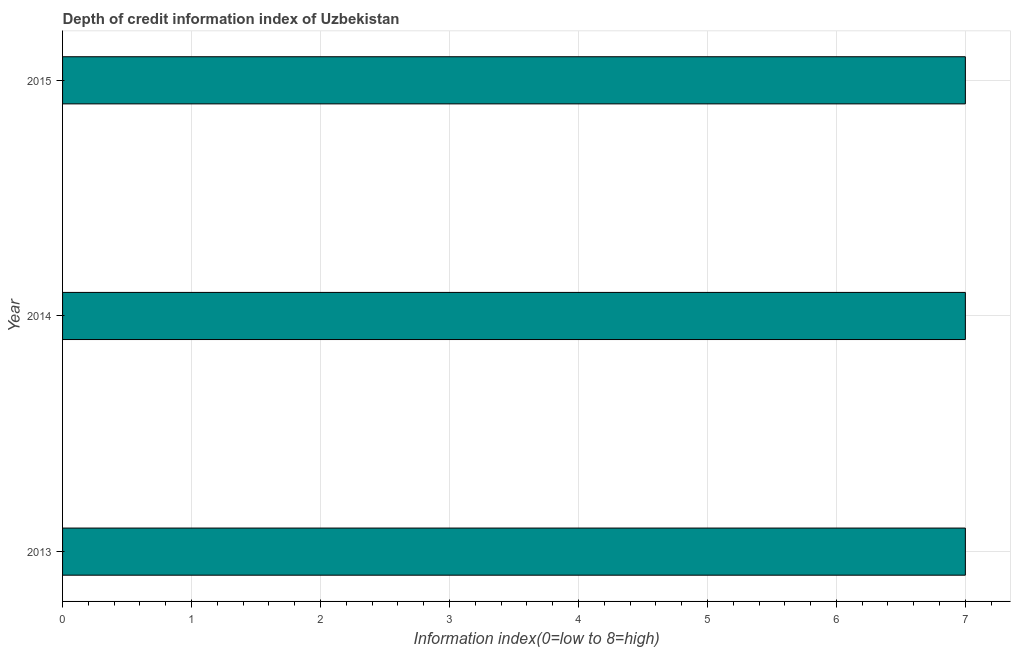Does the graph contain any zero values?
Keep it short and to the point. No. What is the title of the graph?
Your answer should be compact. Depth of credit information index of Uzbekistan. What is the label or title of the X-axis?
Ensure brevity in your answer.  Information index(0=low to 8=high). What is the label or title of the Y-axis?
Offer a very short reply. Year. What is the depth of credit information index in 2015?
Provide a succinct answer. 7. Across all years, what is the minimum depth of credit information index?
Provide a short and direct response. 7. What is the sum of the depth of credit information index?
Make the answer very short. 21. What is the difference between the depth of credit information index in 2014 and 2015?
Offer a very short reply. 0. What is the average depth of credit information index per year?
Provide a short and direct response. 7. What is the median depth of credit information index?
Your answer should be compact. 7. In how many years, is the depth of credit information index greater than 6.2 ?
Ensure brevity in your answer.  3. Do a majority of the years between 2015 and 2014 (inclusive) have depth of credit information index greater than 3.2 ?
Your answer should be compact. No. Is the difference between the depth of credit information index in 2013 and 2014 greater than the difference between any two years?
Make the answer very short. Yes. Is the sum of the depth of credit information index in 2013 and 2015 greater than the maximum depth of credit information index across all years?
Make the answer very short. Yes. What is the difference between the highest and the lowest depth of credit information index?
Make the answer very short. 0. In how many years, is the depth of credit information index greater than the average depth of credit information index taken over all years?
Ensure brevity in your answer.  0. How many bars are there?
Provide a succinct answer. 3. What is the Information index(0=low to 8=high) of 2014?
Provide a succinct answer. 7. What is the Information index(0=low to 8=high) of 2015?
Offer a terse response. 7. What is the ratio of the Information index(0=low to 8=high) in 2013 to that in 2014?
Offer a terse response. 1. What is the ratio of the Information index(0=low to 8=high) in 2013 to that in 2015?
Offer a very short reply. 1. 